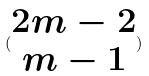Convert formula to latex. <formula><loc_0><loc_0><loc_500><loc_500>( \begin{matrix} 2 m - 2 \\ m - 1 \end{matrix} )</formula> 